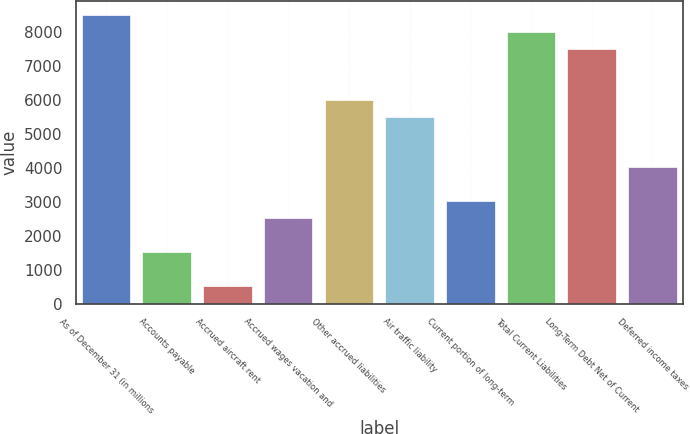<chart> <loc_0><loc_0><loc_500><loc_500><bar_chart><fcel>As of December 31 (in millions<fcel>Accounts payable<fcel>Accrued aircraft rent<fcel>Accrued wages vacation and<fcel>Other accrued liabilities<fcel>Air traffic liability<fcel>Current portion of long-term<fcel>Total Current Liabilities<fcel>Long-Term Debt Net of Current<fcel>Deferred income taxes<nl><fcel>8502.32<fcel>1530.88<fcel>534.96<fcel>2526.8<fcel>6012.52<fcel>5514.56<fcel>3024.76<fcel>8004.36<fcel>7506.4<fcel>4020.68<nl></chart> 